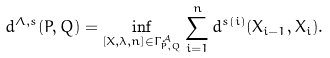<formula> <loc_0><loc_0><loc_500><loc_500>d ^ { \Lambda , s } ( P , Q ) = \inf _ { [ X , \lambda , n ] \in \Gamma ^ { \mathcal { A } } _ { P , Q } } \sum ^ { n } _ { i = 1 } d ^ { s ( i ) } ( X _ { i - 1 } , X _ { i } ) .</formula> 